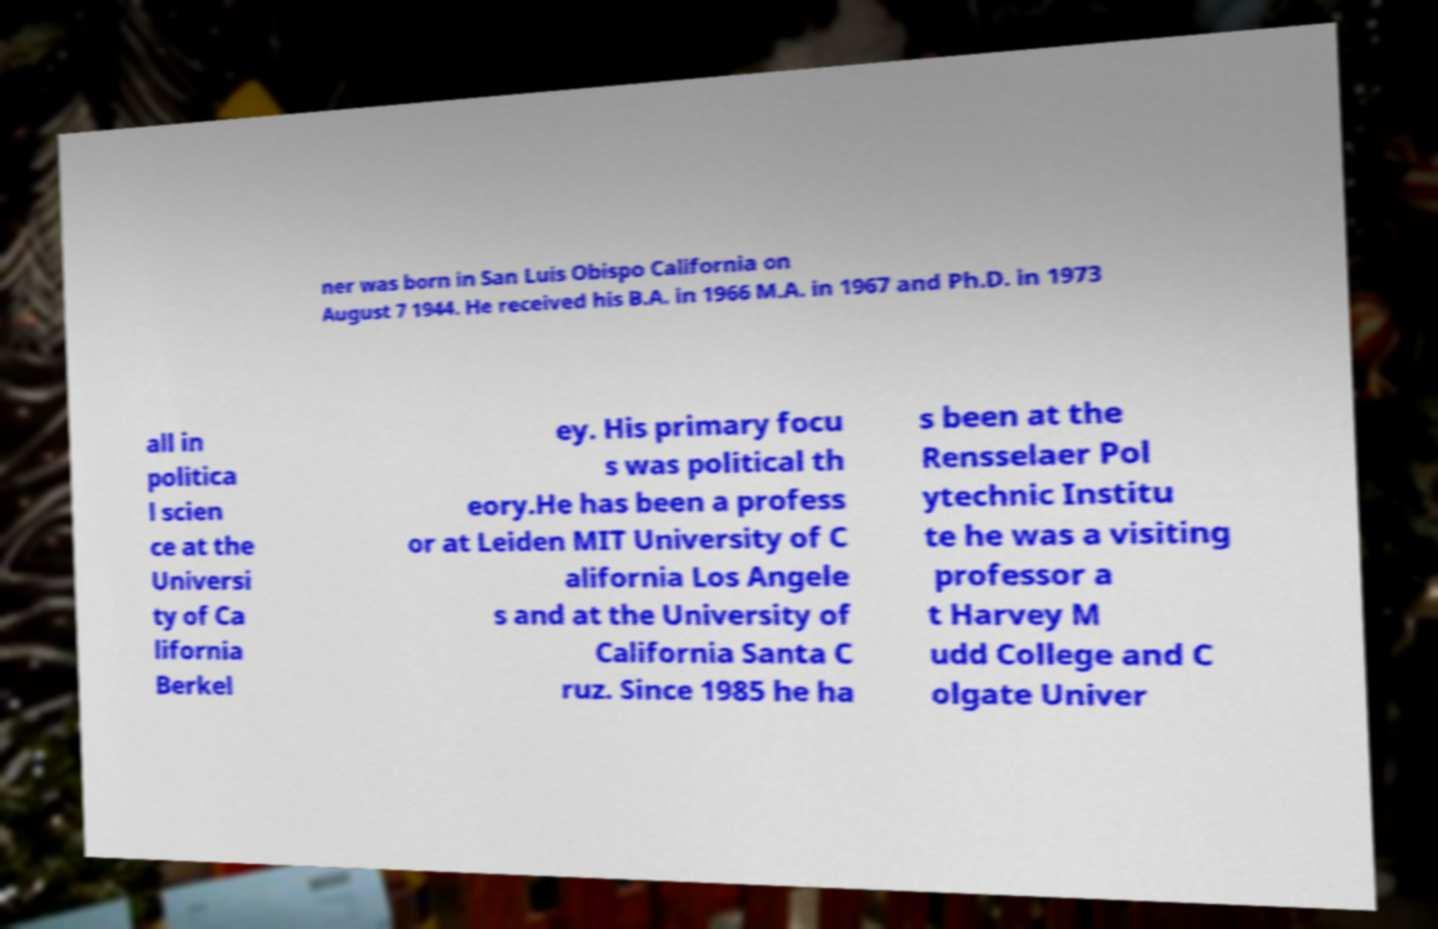For documentation purposes, I need the text within this image transcribed. Could you provide that? ner was born in San Luis Obispo California on August 7 1944. He received his B.A. in 1966 M.A. in 1967 and Ph.D. in 1973 all in politica l scien ce at the Universi ty of Ca lifornia Berkel ey. His primary focu s was political th eory.He has been a profess or at Leiden MIT University of C alifornia Los Angele s and at the University of California Santa C ruz. Since 1985 he ha s been at the Rensselaer Pol ytechnic Institu te he was a visiting professor a t Harvey M udd College and C olgate Univer 